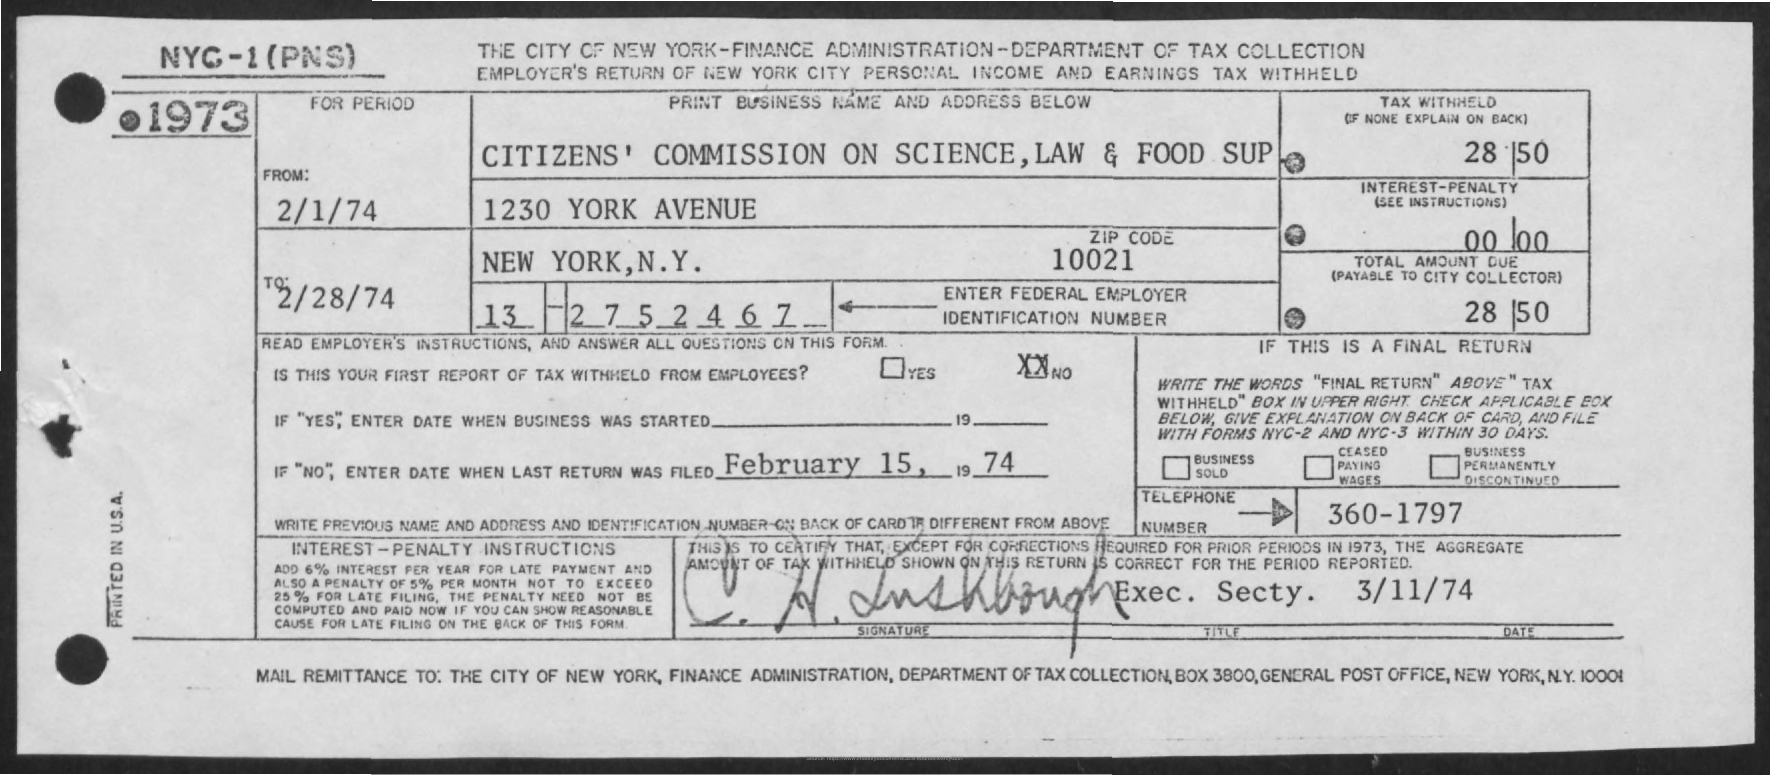Draw attention to some important aspects in this diagram. What is the Interest-Penalty? It is a range of numbers from 0 to represent the amount of interest or penalty assessed on a debt or financial obligation. The amount of tax withheld is 28, and the amount of tax withheld is 50. The last income tax return was filed on February 15, 1974. What is the zip code of 10021? The total amount due is $28.50. 